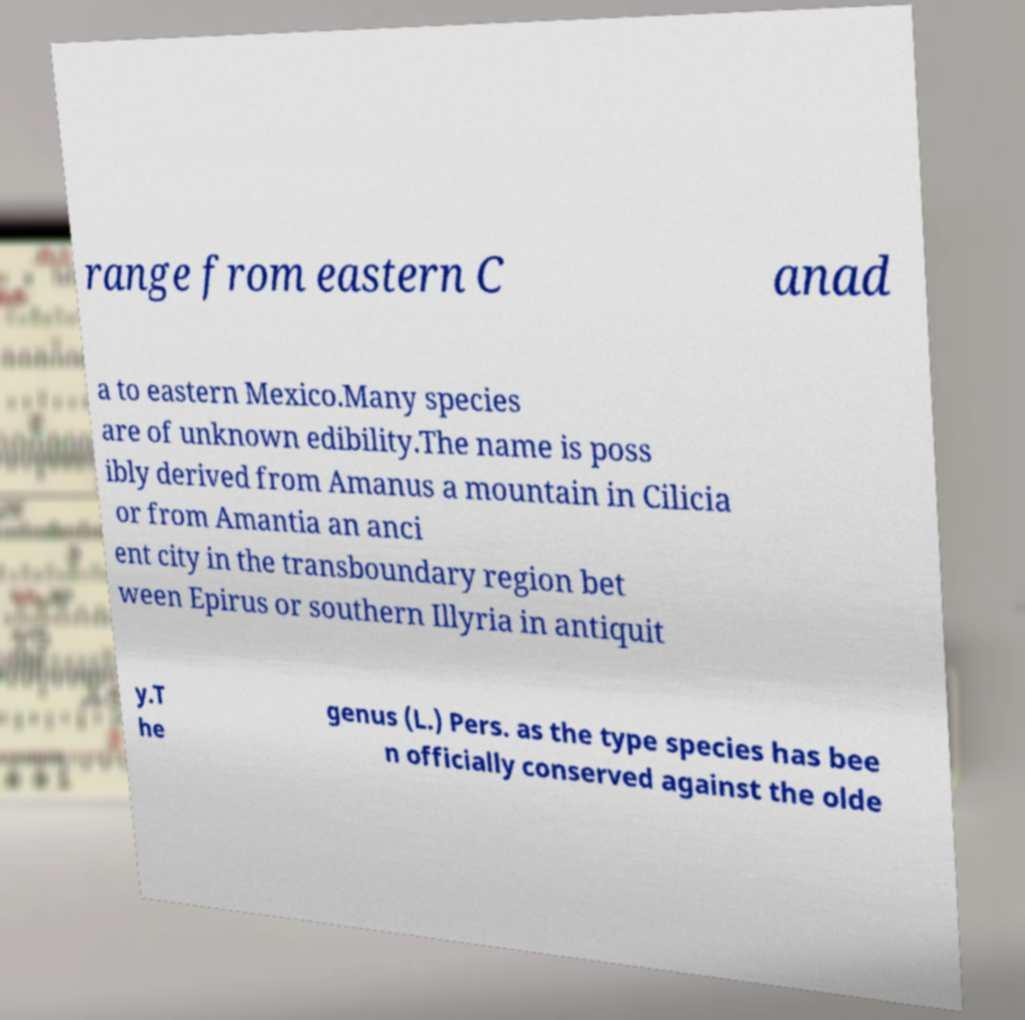What messages or text are displayed in this image? I need them in a readable, typed format. range from eastern C anad a to eastern Mexico.Many species are of unknown edibility.The name is poss ibly derived from Amanus a mountain in Cilicia or from Amantia an anci ent city in the transboundary region bet ween Epirus or southern Illyria in antiquit y.T he genus (L.) Pers. as the type species has bee n officially conserved against the olde 